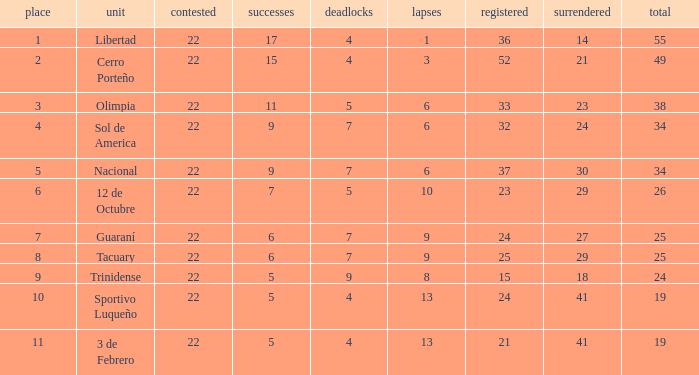What was the number of losses when the scored value was 25? 9.0. 